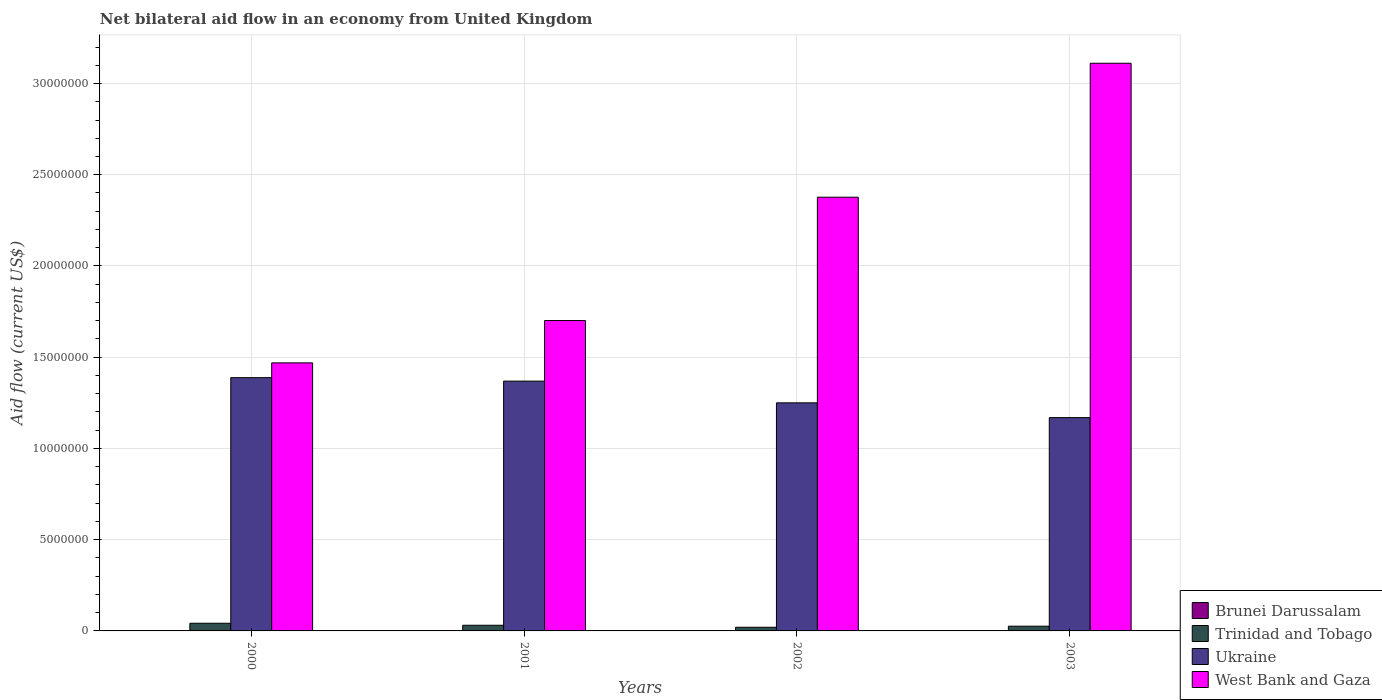How many groups of bars are there?
Provide a succinct answer. 4. Are the number of bars per tick equal to the number of legend labels?
Provide a short and direct response. No. Are the number of bars on each tick of the X-axis equal?
Ensure brevity in your answer.  No. How many bars are there on the 2nd tick from the right?
Your answer should be very brief. 3. What is the net bilateral aid flow in Ukraine in 2001?
Offer a very short reply. 1.37e+07. Across all years, what is the maximum net bilateral aid flow in Brunei Darussalam?
Your answer should be very brief. 2.00e+04. Across all years, what is the minimum net bilateral aid flow in West Bank and Gaza?
Make the answer very short. 1.47e+07. In which year was the net bilateral aid flow in Ukraine maximum?
Your answer should be very brief. 2000. What is the total net bilateral aid flow in Trinidad and Tobago in the graph?
Provide a short and direct response. 1.19e+06. What is the difference between the net bilateral aid flow in West Bank and Gaza in 2000 and that in 2002?
Keep it short and to the point. -9.08e+06. What is the difference between the net bilateral aid flow in Ukraine in 2000 and the net bilateral aid flow in Brunei Darussalam in 2002?
Your answer should be compact. 1.39e+07. What is the average net bilateral aid flow in Trinidad and Tobago per year?
Keep it short and to the point. 2.98e+05. In the year 2000, what is the difference between the net bilateral aid flow in Ukraine and net bilateral aid flow in West Bank and Gaza?
Your response must be concise. -8.10e+05. In how many years, is the net bilateral aid flow in Ukraine greater than 30000000 US$?
Your answer should be very brief. 0. What is the ratio of the net bilateral aid flow in Ukraine in 2000 to that in 2002?
Your response must be concise. 1.11. Is the difference between the net bilateral aid flow in Ukraine in 2000 and 2003 greater than the difference between the net bilateral aid flow in West Bank and Gaza in 2000 and 2003?
Ensure brevity in your answer.  Yes. What is the difference between the highest and the lowest net bilateral aid flow in West Bank and Gaza?
Ensure brevity in your answer.  1.64e+07. In how many years, is the net bilateral aid flow in Trinidad and Tobago greater than the average net bilateral aid flow in Trinidad and Tobago taken over all years?
Offer a terse response. 2. How many bars are there?
Give a very brief answer. 15. How many years are there in the graph?
Your answer should be compact. 4. What is the difference between two consecutive major ticks on the Y-axis?
Your response must be concise. 5.00e+06. Are the values on the major ticks of Y-axis written in scientific E-notation?
Provide a succinct answer. No. Does the graph contain any zero values?
Give a very brief answer. Yes. Does the graph contain grids?
Keep it short and to the point. Yes. Where does the legend appear in the graph?
Your response must be concise. Bottom right. How many legend labels are there?
Make the answer very short. 4. What is the title of the graph?
Provide a short and direct response. Net bilateral aid flow in an economy from United Kingdom. What is the label or title of the X-axis?
Offer a very short reply. Years. What is the label or title of the Y-axis?
Your answer should be compact. Aid flow (current US$). What is the Aid flow (current US$) of Brunei Darussalam in 2000?
Give a very brief answer. 10000. What is the Aid flow (current US$) of Trinidad and Tobago in 2000?
Keep it short and to the point. 4.20e+05. What is the Aid flow (current US$) in Ukraine in 2000?
Your response must be concise. 1.39e+07. What is the Aid flow (current US$) of West Bank and Gaza in 2000?
Offer a terse response. 1.47e+07. What is the Aid flow (current US$) of Brunei Darussalam in 2001?
Give a very brief answer. 2.00e+04. What is the Aid flow (current US$) of Trinidad and Tobago in 2001?
Your response must be concise. 3.10e+05. What is the Aid flow (current US$) in Ukraine in 2001?
Your response must be concise. 1.37e+07. What is the Aid flow (current US$) in West Bank and Gaza in 2001?
Your response must be concise. 1.70e+07. What is the Aid flow (current US$) in Ukraine in 2002?
Ensure brevity in your answer.  1.25e+07. What is the Aid flow (current US$) in West Bank and Gaza in 2002?
Your answer should be compact. 2.38e+07. What is the Aid flow (current US$) in Brunei Darussalam in 2003?
Provide a short and direct response. 2.00e+04. What is the Aid flow (current US$) in Ukraine in 2003?
Give a very brief answer. 1.17e+07. What is the Aid flow (current US$) of West Bank and Gaza in 2003?
Provide a succinct answer. 3.11e+07. Across all years, what is the maximum Aid flow (current US$) of Ukraine?
Ensure brevity in your answer.  1.39e+07. Across all years, what is the maximum Aid flow (current US$) of West Bank and Gaza?
Give a very brief answer. 3.11e+07. Across all years, what is the minimum Aid flow (current US$) of Brunei Darussalam?
Make the answer very short. 0. Across all years, what is the minimum Aid flow (current US$) in Trinidad and Tobago?
Keep it short and to the point. 2.00e+05. Across all years, what is the minimum Aid flow (current US$) of Ukraine?
Offer a terse response. 1.17e+07. Across all years, what is the minimum Aid flow (current US$) of West Bank and Gaza?
Your answer should be very brief. 1.47e+07. What is the total Aid flow (current US$) in Trinidad and Tobago in the graph?
Your response must be concise. 1.19e+06. What is the total Aid flow (current US$) in Ukraine in the graph?
Keep it short and to the point. 5.18e+07. What is the total Aid flow (current US$) of West Bank and Gaza in the graph?
Provide a short and direct response. 8.66e+07. What is the difference between the Aid flow (current US$) of Ukraine in 2000 and that in 2001?
Offer a terse response. 1.90e+05. What is the difference between the Aid flow (current US$) in West Bank and Gaza in 2000 and that in 2001?
Keep it short and to the point. -2.32e+06. What is the difference between the Aid flow (current US$) in Trinidad and Tobago in 2000 and that in 2002?
Make the answer very short. 2.20e+05. What is the difference between the Aid flow (current US$) of Ukraine in 2000 and that in 2002?
Give a very brief answer. 1.38e+06. What is the difference between the Aid flow (current US$) of West Bank and Gaza in 2000 and that in 2002?
Your response must be concise. -9.08e+06. What is the difference between the Aid flow (current US$) of Brunei Darussalam in 2000 and that in 2003?
Ensure brevity in your answer.  -10000. What is the difference between the Aid flow (current US$) in Ukraine in 2000 and that in 2003?
Make the answer very short. 2.19e+06. What is the difference between the Aid flow (current US$) in West Bank and Gaza in 2000 and that in 2003?
Provide a short and direct response. -1.64e+07. What is the difference between the Aid flow (current US$) in Trinidad and Tobago in 2001 and that in 2002?
Your answer should be compact. 1.10e+05. What is the difference between the Aid flow (current US$) of Ukraine in 2001 and that in 2002?
Provide a succinct answer. 1.19e+06. What is the difference between the Aid flow (current US$) in West Bank and Gaza in 2001 and that in 2002?
Provide a succinct answer. -6.76e+06. What is the difference between the Aid flow (current US$) in Brunei Darussalam in 2001 and that in 2003?
Give a very brief answer. 0. What is the difference between the Aid flow (current US$) in Trinidad and Tobago in 2001 and that in 2003?
Make the answer very short. 5.00e+04. What is the difference between the Aid flow (current US$) in West Bank and Gaza in 2001 and that in 2003?
Make the answer very short. -1.41e+07. What is the difference between the Aid flow (current US$) in Ukraine in 2002 and that in 2003?
Keep it short and to the point. 8.10e+05. What is the difference between the Aid flow (current US$) of West Bank and Gaza in 2002 and that in 2003?
Ensure brevity in your answer.  -7.34e+06. What is the difference between the Aid flow (current US$) in Brunei Darussalam in 2000 and the Aid flow (current US$) in Trinidad and Tobago in 2001?
Keep it short and to the point. -3.00e+05. What is the difference between the Aid flow (current US$) of Brunei Darussalam in 2000 and the Aid flow (current US$) of Ukraine in 2001?
Your answer should be compact. -1.37e+07. What is the difference between the Aid flow (current US$) in Brunei Darussalam in 2000 and the Aid flow (current US$) in West Bank and Gaza in 2001?
Your answer should be very brief. -1.70e+07. What is the difference between the Aid flow (current US$) in Trinidad and Tobago in 2000 and the Aid flow (current US$) in Ukraine in 2001?
Provide a succinct answer. -1.33e+07. What is the difference between the Aid flow (current US$) of Trinidad and Tobago in 2000 and the Aid flow (current US$) of West Bank and Gaza in 2001?
Provide a succinct answer. -1.66e+07. What is the difference between the Aid flow (current US$) of Ukraine in 2000 and the Aid flow (current US$) of West Bank and Gaza in 2001?
Keep it short and to the point. -3.13e+06. What is the difference between the Aid flow (current US$) of Brunei Darussalam in 2000 and the Aid flow (current US$) of Ukraine in 2002?
Your response must be concise. -1.25e+07. What is the difference between the Aid flow (current US$) of Brunei Darussalam in 2000 and the Aid flow (current US$) of West Bank and Gaza in 2002?
Keep it short and to the point. -2.38e+07. What is the difference between the Aid flow (current US$) of Trinidad and Tobago in 2000 and the Aid flow (current US$) of Ukraine in 2002?
Provide a short and direct response. -1.21e+07. What is the difference between the Aid flow (current US$) in Trinidad and Tobago in 2000 and the Aid flow (current US$) in West Bank and Gaza in 2002?
Ensure brevity in your answer.  -2.34e+07. What is the difference between the Aid flow (current US$) of Ukraine in 2000 and the Aid flow (current US$) of West Bank and Gaza in 2002?
Provide a succinct answer. -9.89e+06. What is the difference between the Aid flow (current US$) of Brunei Darussalam in 2000 and the Aid flow (current US$) of Trinidad and Tobago in 2003?
Provide a succinct answer. -2.50e+05. What is the difference between the Aid flow (current US$) in Brunei Darussalam in 2000 and the Aid flow (current US$) in Ukraine in 2003?
Your answer should be compact. -1.17e+07. What is the difference between the Aid flow (current US$) in Brunei Darussalam in 2000 and the Aid flow (current US$) in West Bank and Gaza in 2003?
Ensure brevity in your answer.  -3.11e+07. What is the difference between the Aid flow (current US$) in Trinidad and Tobago in 2000 and the Aid flow (current US$) in Ukraine in 2003?
Provide a succinct answer. -1.13e+07. What is the difference between the Aid flow (current US$) of Trinidad and Tobago in 2000 and the Aid flow (current US$) of West Bank and Gaza in 2003?
Your answer should be compact. -3.07e+07. What is the difference between the Aid flow (current US$) in Ukraine in 2000 and the Aid flow (current US$) in West Bank and Gaza in 2003?
Offer a very short reply. -1.72e+07. What is the difference between the Aid flow (current US$) in Brunei Darussalam in 2001 and the Aid flow (current US$) in Ukraine in 2002?
Ensure brevity in your answer.  -1.25e+07. What is the difference between the Aid flow (current US$) in Brunei Darussalam in 2001 and the Aid flow (current US$) in West Bank and Gaza in 2002?
Your answer should be compact. -2.38e+07. What is the difference between the Aid flow (current US$) of Trinidad and Tobago in 2001 and the Aid flow (current US$) of Ukraine in 2002?
Your response must be concise. -1.22e+07. What is the difference between the Aid flow (current US$) in Trinidad and Tobago in 2001 and the Aid flow (current US$) in West Bank and Gaza in 2002?
Provide a short and direct response. -2.35e+07. What is the difference between the Aid flow (current US$) of Ukraine in 2001 and the Aid flow (current US$) of West Bank and Gaza in 2002?
Your answer should be compact. -1.01e+07. What is the difference between the Aid flow (current US$) in Brunei Darussalam in 2001 and the Aid flow (current US$) in Ukraine in 2003?
Give a very brief answer. -1.17e+07. What is the difference between the Aid flow (current US$) in Brunei Darussalam in 2001 and the Aid flow (current US$) in West Bank and Gaza in 2003?
Ensure brevity in your answer.  -3.11e+07. What is the difference between the Aid flow (current US$) of Trinidad and Tobago in 2001 and the Aid flow (current US$) of Ukraine in 2003?
Ensure brevity in your answer.  -1.14e+07. What is the difference between the Aid flow (current US$) of Trinidad and Tobago in 2001 and the Aid flow (current US$) of West Bank and Gaza in 2003?
Ensure brevity in your answer.  -3.08e+07. What is the difference between the Aid flow (current US$) in Ukraine in 2001 and the Aid flow (current US$) in West Bank and Gaza in 2003?
Provide a succinct answer. -1.74e+07. What is the difference between the Aid flow (current US$) of Trinidad and Tobago in 2002 and the Aid flow (current US$) of Ukraine in 2003?
Make the answer very short. -1.15e+07. What is the difference between the Aid flow (current US$) of Trinidad and Tobago in 2002 and the Aid flow (current US$) of West Bank and Gaza in 2003?
Provide a succinct answer. -3.09e+07. What is the difference between the Aid flow (current US$) in Ukraine in 2002 and the Aid flow (current US$) in West Bank and Gaza in 2003?
Provide a short and direct response. -1.86e+07. What is the average Aid flow (current US$) in Brunei Darussalam per year?
Offer a terse response. 1.25e+04. What is the average Aid flow (current US$) in Trinidad and Tobago per year?
Your answer should be compact. 2.98e+05. What is the average Aid flow (current US$) in Ukraine per year?
Your answer should be very brief. 1.29e+07. What is the average Aid flow (current US$) in West Bank and Gaza per year?
Keep it short and to the point. 2.16e+07. In the year 2000, what is the difference between the Aid flow (current US$) in Brunei Darussalam and Aid flow (current US$) in Trinidad and Tobago?
Ensure brevity in your answer.  -4.10e+05. In the year 2000, what is the difference between the Aid flow (current US$) in Brunei Darussalam and Aid flow (current US$) in Ukraine?
Ensure brevity in your answer.  -1.39e+07. In the year 2000, what is the difference between the Aid flow (current US$) of Brunei Darussalam and Aid flow (current US$) of West Bank and Gaza?
Offer a very short reply. -1.47e+07. In the year 2000, what is the difference between the Aid flow (current US$) of Trinidad and Tobago and Aid flow (current US$) of Ukraine?
Your response must be concise. -1.35e+07. In the year 2000, what is the difference between the Aid flow (current US$) in Trinidad and Tobago and Aid flow (current US$) in West Bank and Gaza?
Offer a very short reply. -1.43e+07. In the year 2000, what is the difference between the Aid flow (current US$) in Ukraine and Aid flow (current US$) in West Bank and Gaza?
Your answer should be very brief. -8.10e+05. In the year 2001, what is the difference between the Aid flow (current US$) in Brunei Darussalam and Aid flow (current US$) in Trinidad and Tobago?
Offer a very short reply. -2.90e+05. In the year 2001, what is the difference between the Aid flow (current US$) in Brunei Darussalam and Aid flow (current US$) in Ukraine?
Your answer should be compact. -1.37e+07. In the year 2001, what is the difference between the Aid flow (current US$) in Brunei Darussalam and Aid flow (current US$) in West Bank and Gaza?
Ensure brevity in your answer.  -1.70e+07. In the year 2001, what is the difference between the Aid flow (current US$) of Trinidad and Tobago and Aid flow (current US$) of Ukraine?
Offer a very short reply. -1.34e+07. In the year 2001, what is the difference between the Aid flow (current US$) in Trinidad and Tobago and Aid flow (current US$) in West Bank and Gaza?
Offer a very short reply. -1.67e+07. In the year 2001, what is the difference between the Aid flow (current US$) in Ukraine and Aid flow (current US$) in West Bank and Gaza?
Offer a terse response. -3.32e+06. In the year 2002, what is the difference between the Aid flow (current US$) of Trinidad and Tobago and Aid flow (current US$) of Ukraine?
Provide a short and direct response. -1.23e+07. In the year 2002, what is the difference between the Aid flow (current US$) in Trinidad and Tobago and Aid flow (current US$) in West Bank and Gaza?
Your answer should be very brief. -2.36e+07. In the year 2002, what is the difference between the Aid flow (current US$) in Ukraine and Aid flow (current US$) in West Bank and Gaza?
Your answer should be compact. -1.13e+07. In the year 2003, what is the difference between the Aid flow (current US$) of Brunei Darussalam and Aid flow (current US$) of Trinidad and Tobago?
Ensure brevity in your answer.  -2.40e+05. In the year 2003, what is the difference between the Aid flow (current US$) in Brunei Darussalam and Aid flow (current US$) in Ukraine?
Your response must be concise. -1.17e+07. In the year 2003, what is the difference between the Aid flow (current US$) in Brunei Darussalam and Aid flow (current US$) in West Bank and Gaza?
Offer a terse response. -3.11e+07. In the year 2003, what is the difference between the Aid flow (current US$) of Trinidad and Tobago and Aid flow (current US$) of Ukraine?
Provide a short and direct response. -1.14e+07. In the year 2003, what is the difference between the Aid flow (current US$) of Trinidad and Tobago and Aid flow (current US$) of West Bank and Gaza?
Your answer should be compact. -3.08e+07. In the year 2003, what is the difference between the Aid flow (current US$) of Ukraine and Aid flow (current US$) of West Bank and Gaza?
Your answer should be compact. -1.94e+07. What is the ratio of the Aid flow (current US$) of Trinidad and Tobago in 2000 to that in 2001?
Ensure brevity in your answer.  1.35. What is the ratio of the Aid flow (current US$) in Ukraine in 2000 to that in 2001?
Your response must be concise. 1.01. What is the ratio of the Aid flow (current US$) of West Bank and Gaza in 2000 to that in 2001?
Give a very brief answer. 0.86. What is the ratio of the Aid flow (current US$) of Ukraine in 2000 to that in 2002?
Your answer should be very brief. 1.11. What is the ratio of the Aid flow (current US$) of West Bank and Gaza in 2000 to that in 2002?
Make the answer very short. 0.62. What is the ratio of the Aid flow (current US$) of Trinidad and Tobago in 2000 to that in 2003?
Ensure brevity in your answer.  1.62. What is the ratio of the Aid flow (current US$) in Ukraine in 2000 to that in 2003?
Your response must be concise. 1.19. What is the ratio of the Aid flow (current US$) in West Bank and Gaza in 2000 to that in 2003?
Offer a very short reply. 0.47. What is the ratio of the Aid flow (current US$) of Trinidad and Tobago in 2001 to that in 2002?
Provide a succinct answer. 1.55. What is the ratio of the Aid flow (current US$) in Ukraine in 2001 to that in 2002?
Give a very brief answer. 1.1. What is the ratio of the Aid flow (current US$) in West Bank and Gaza in 2001 to that in 2002?
Your answer should be very brief. 0.72. What is the ratio of the Aid flow (current US$) in Trinidad and Tobago in 2001 to that in 2003?
Provide a succinct answer. 1.19. What is the ratio of the Aid flow (current US$) in Ukraine in 2001 to that in 2003?
Your response must be concise. 1.17. What is the ratio of the Aid flow (current US$) of West Bank and Gaza in 2001 to that in 2003?
Your response must be concise. 0.55. What is the ratio of the Aid flow (current US$) of Trinidad and Tobago in 2002 to that in 2003?
Your answer should be compact. 0.77. What is the ratio of the Aid flow (current US$) in Ukraine in 2002 to that in 2003?
Offer a very short reply. 1.07. What is the ratio of the Aid flow (current US$) in West Bank and Gaza in 2002 to that in 2003?
Your answer should be very brief. 0.76. What is the difference between the highest and the second highest Aid flow (current US$) in Brunei Darussalam?
Offer a very short reply. 0. What is the difference between the highest and the second highest Aid flow (current US$) of Trinidad and Tobago?
Offer a terse response. 1.10e+05. What is the difference between the highest and the second highest Aid flow (current US$) in Ukraine?
Make the answer very short. 1.90e+05. What is the difference between the highest and the second highest Aid flow (current US$) of West Bank and Gaza?
Make the answer very short. 7.34e+06. What is the difference between the highest and the lowest Aid flow (current US$) of Brunei Darussalam?
Ensure brevity in your answer.  2.00e+04. What is the difference between the highest and the lowest Aid flow (current US$) in Trinidad and Tobago?
Ensure brevity in your answer.  2.20e+05. What is the difference between the highest and the lowest Aid flow (current US$) in Ukraine?
Provide a short and direct response. 2.19e+06. What is the difference between the highest and the lowest Aid flow (current US$) in West Bank and Gaza?
Make the answer very short. 1.64e+07. 